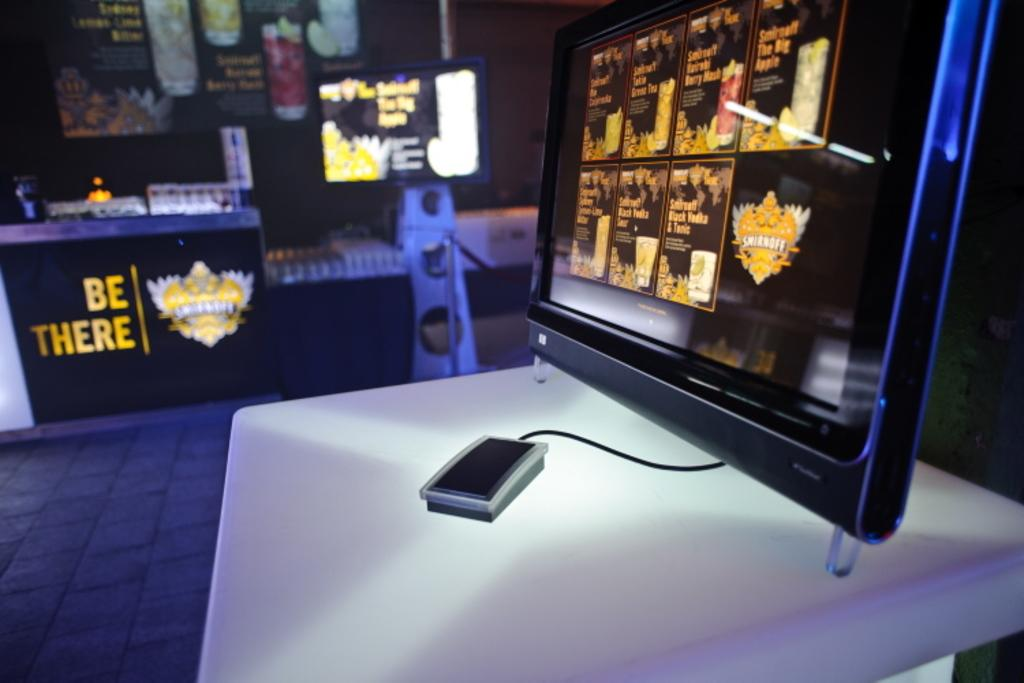<image>
Offer a succinct explanation of the picture presented. A computer monitor with a banner that says BE THERE in the background 